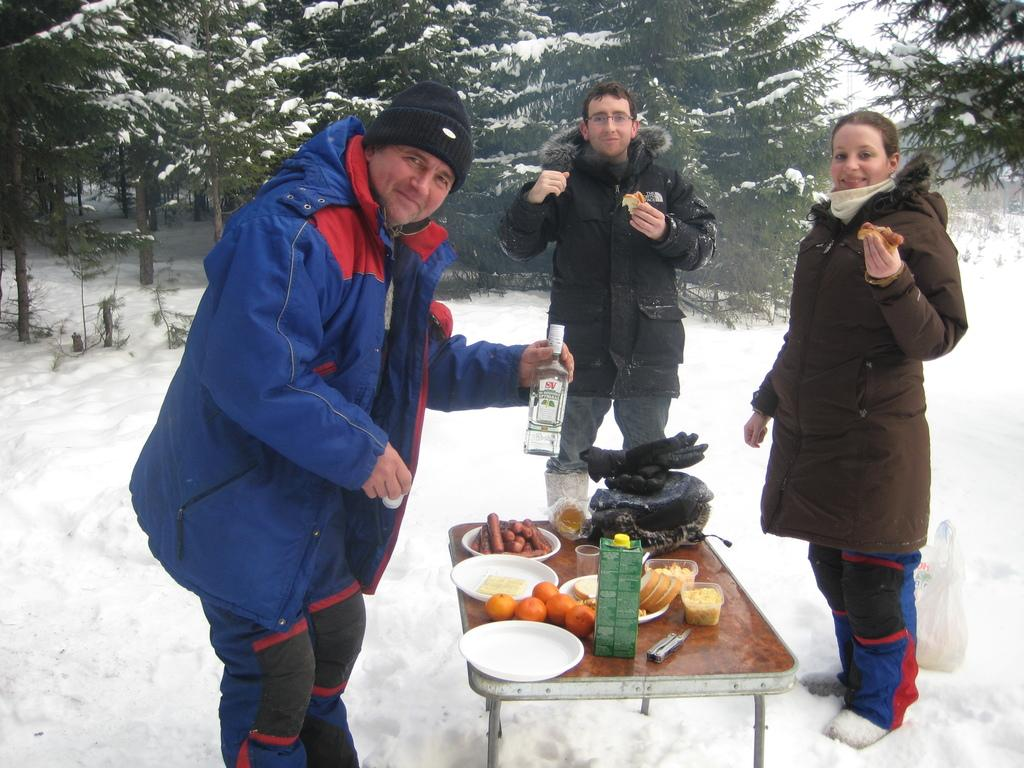What is present on the table in the image? There are foods on the table in the image. What are the people in the image doing? There are three people standing and looking at someone. What is the man on the left side holding? The man on the left side is holding a bottle. What type of mine is visible in the image? There is no mine present in the image. What scientific experiment is being conducted in the image? There is no scientific experiment being conducted in the image. 